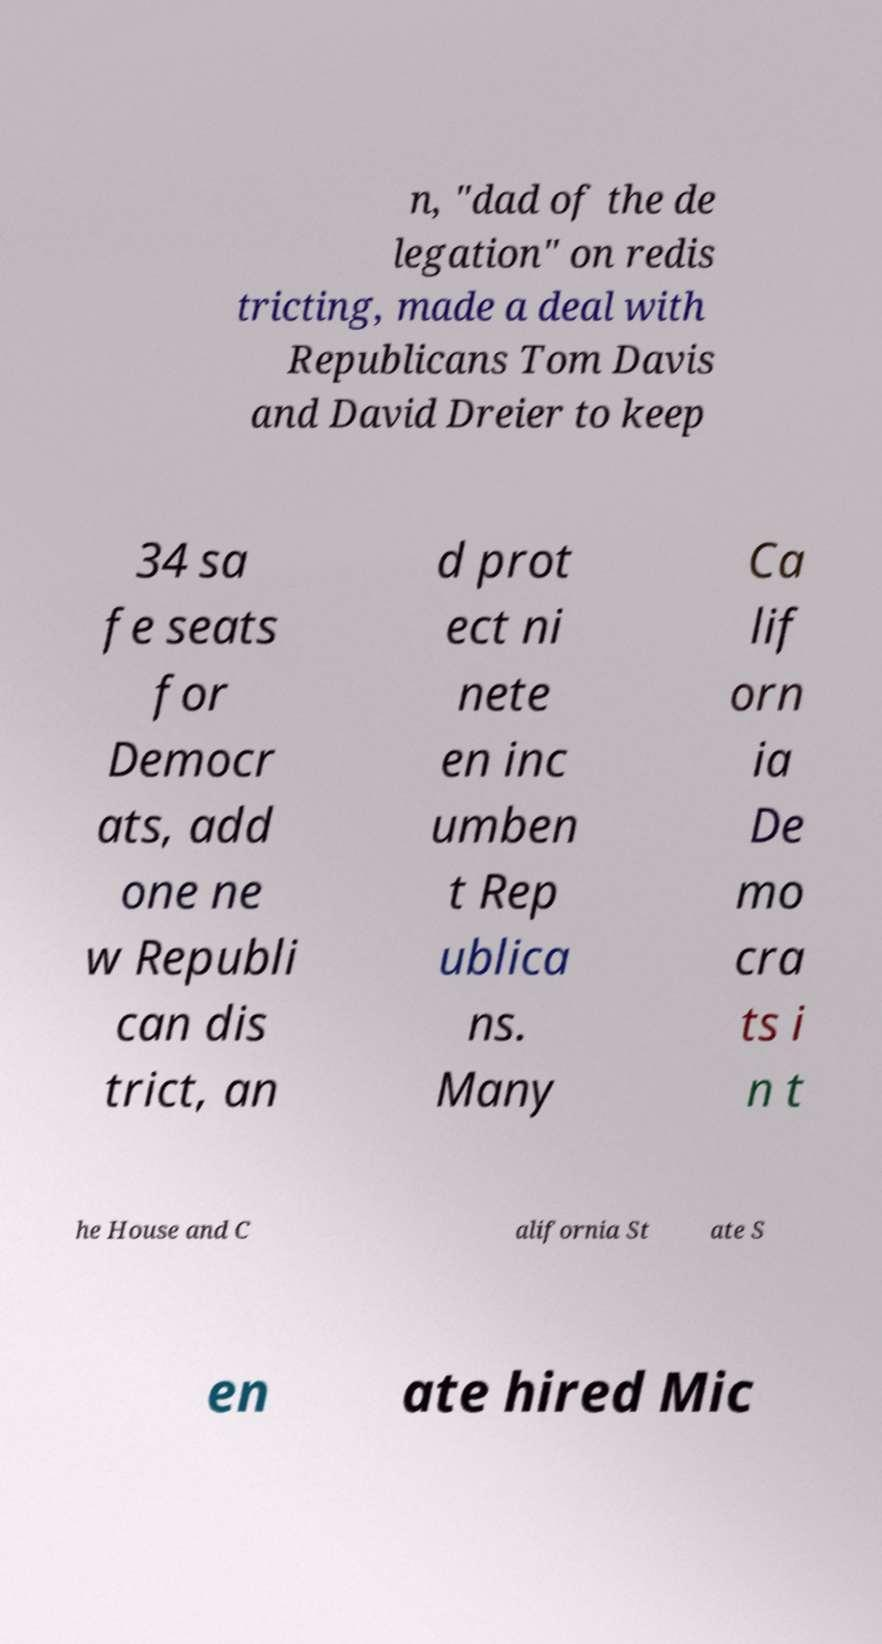Please identify and transcribe the text found in this image. n, "dad of the de legation" on redis tricting, made a deal with Republicans Tom Davis and David Dreier to keep 34 sa fe seats for Democr ats, add one ne w Republi can dis trict, an d prot ect ni nete en inc umben t Rep ublica ns. Many Ca lif orn ia De mo cra ts i n t he House and C alifornia St ate S en ate hired Mic 